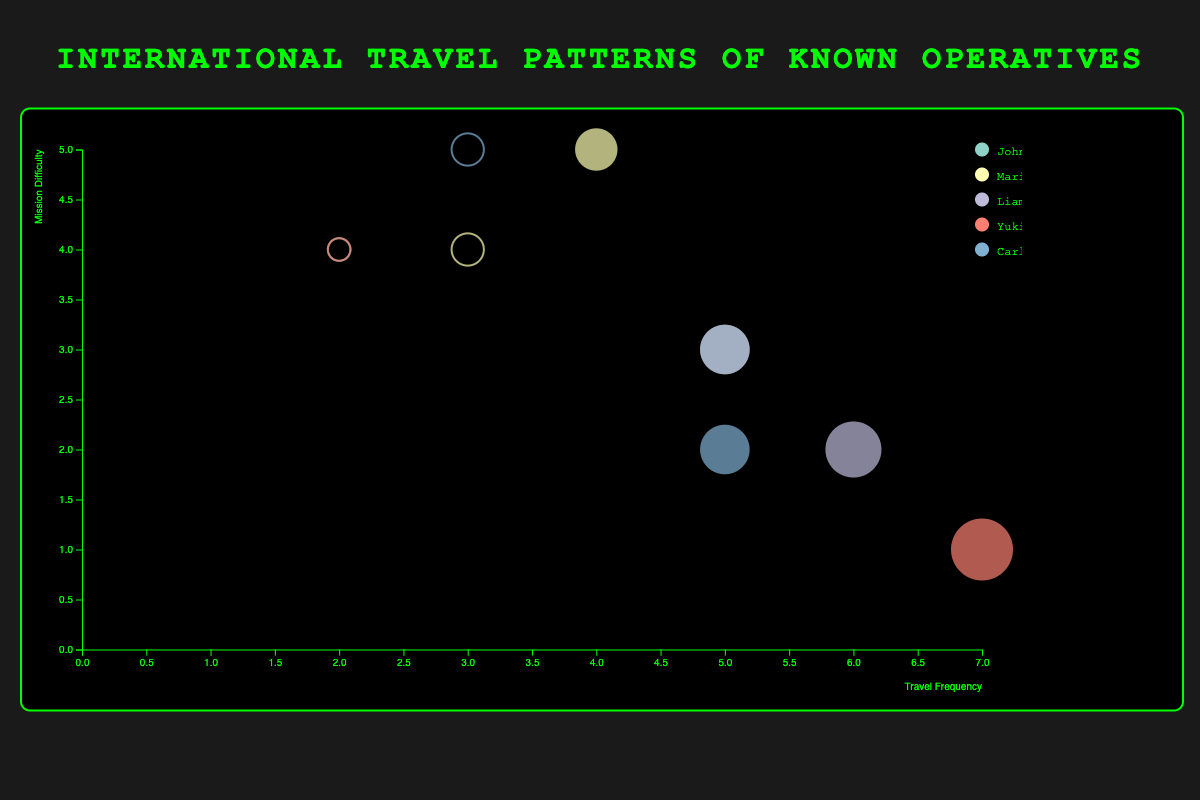How many operatives have missions displayed on the chart? Look at the legend, which lists the operatives by name. Count the number of different names.
Answer: 5 What mission has the highest travel frequency among operatives? Look at the x-axis, identify the bubble positioned furthest to the right. The tooltip will show its details.
Answer: Tokyo mission by Yuki Nakamura Which operative has the most successful missions? Examine the bubbles filled with color and count by operative name from the legend. Liam O'Reilly has the most successful missions (2).
Answer: Liam O'Reilly What is the minimum mission difficulty shown in the chart? Look at the y-axis and identify the bubble positioned lowest. The tooltip details reveal a mission difficulty of 1.
Answer: 1 Between Marie Dupont and Carlos Mendoza, which one has a mission with the highest difficulty? Compare the y-axis positions of Marie Dupont's and Carlos Mendoza's missions. Higher y-values indicate higher difficulty. Marie Dupont's mission in Moscow and Carlos Mendoza's mission in Rio both have the highest difficulty (5).
Answer: Both have missions with a difficulty of 5 Which city has the most frequent travel by any single operative? Look at the x-axis and identify the bubble positioned furthest right. The tooltip reveals this city.
Answer: Tokyo What is the radius of the bubble representing the Tokyo mission? Hover over the bubble positioned furthest right on the x-axis. The radius is calculated based on the travel frequency of 7. Use the sqrt scale provided in the code.
Answer: 30 How many successful missions are there compared to failed ones? Count the colored (successful) and non-colored (failed) bubbles: There are 7 successful and 5 failed missions.
Answer: 7 successful, 5 failed Is there a correlation between travel frequency and mission success? Observe the bubbles with color (successful) and their x-axis positions. Higher travel frequencies often align with successes based on the chart visualization.
Answer: Higher travel frequency largely correlates with success Which operative has missions with the highest average difficulty? Calculate the average difficulty for each operative: John Smith (3.5), Marie Dupont (4.5), Liam O'Reilly (2.5), Yuki Nakamura (2.5), Carlos Mendoza (3.5). Marie Dupont has the highest average difficulty.
Answer: Marie Dupont 